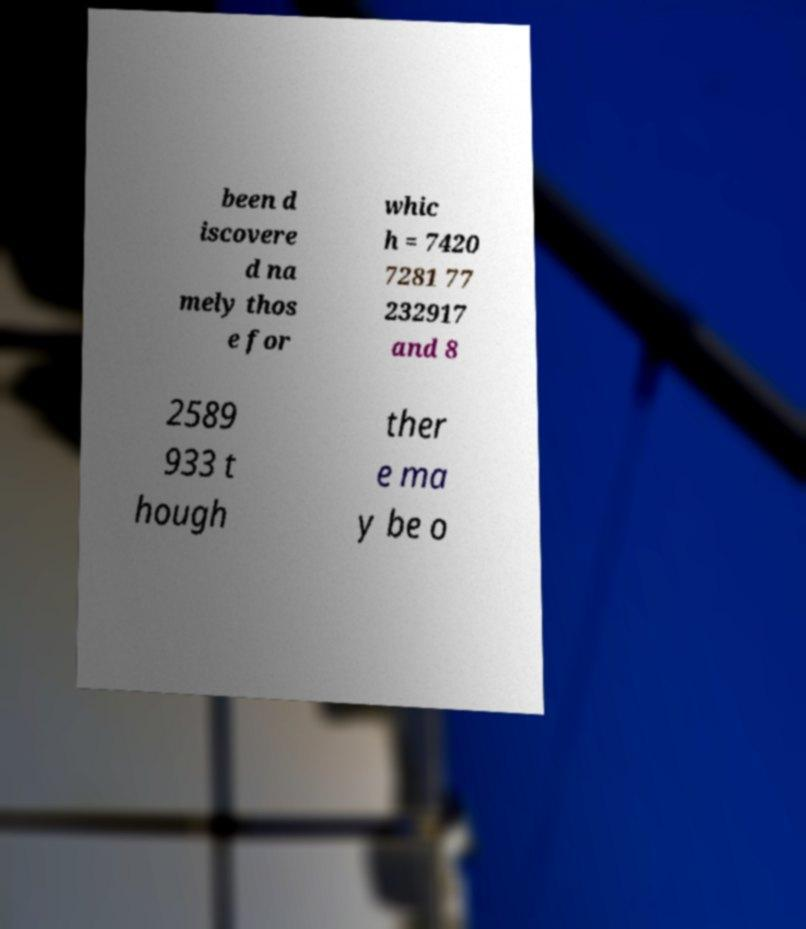Could you assist in decoding the text presented in this image and type it out clearly? been d iscovere d na mely thos e for whic h = 7420 7281 77 232917 and 8 2589 933 t hough ther e ma y be o 